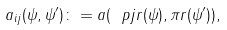Convert formula to latex. <formula><loc_0><loc_0><loc_500><loc_500>a _ { i j } ( \psi , \psi ^ { \prime } ) \colon = a ( \ p j r ( \psi ) , \pi r ( \psi ^ { \prime } ) ) ,</formula> 